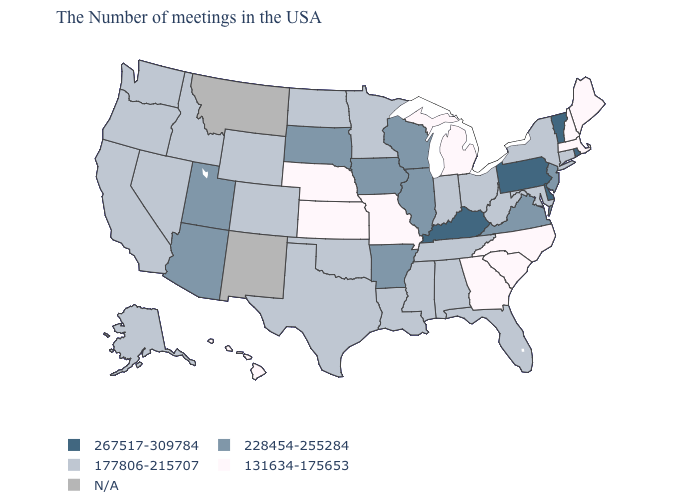What is the lowest value in the West?
Short answer required. 131634-175653. What is the value of Oklahoma?
Give a very brief answer. 177806-215707. What is the value of North Dakota?
Give a very brief answer. 177806-215707. Name the states that have a value in the range 267517-309784?
Answer briefly. Rhode Island, Vermont, Delaware, Pennsylvania, Kentucky. Name the states that have a value in the range 131634-175653?
Give a very brief answer. Maine, Massachusetts, New Hampshire, North Carolina, South Carolina, Georgia, Michigan, Missouri, Kansas, Nebraska, Hawaii. Name the states that have a value in the range 228454-255284?
Quick response, please. New Jersey, Virginia, Wisconsin, Illinois, Arkansas, Iowa, South Dakota, Utah, Arizona. Among the states that border Louisiana , which have the highest value?
Give a very brief answer. Arkansas. Does the first symbol in the legend represent the smallest category?
Short answer required. No. Name the states that have a value in the range 267517-309784?
Be succinct. Rhode Island, Vermont, Delaware, Pennsylvania, Kentucky. Name the states that have a value in the range 177806-215707?
Quick response, please. Connecticut, New York, Maryland, West Virginia, Ohio, Florida, Indiana, Alabama, Tennessee, Mississippi, Louisiana, Minnesota, Oklahoma, Texas, North Dakota, Wyoming, Colorado, Idaho, Nevada, California, Washington, Oregon, Alaska. What is the value of Massachusetts?
Keep it brief. 131634-175653. Name the states that have a value in the range 177806-215707?
Short answer required. Connecticut, New York, Maryland, West Virginia, Ohio, Florida, Indiana, Alabama, Tennessee, Mississippi, Louisiana, Minnesota, Oklahoma, Texas, North Dakota, Wyoming, Colorado, Idaho, Nevada, California, Washington, Oregon, Alaska. Name the states that have a value in the range 228454-255284?
Keep it brief. New Jersey, Virginia, Wisconsin, Illinois, Arkansas, Iowa, South Dakota, Utah, Arizona. How many symbols are there in the legend?
Be succinct. 5. 